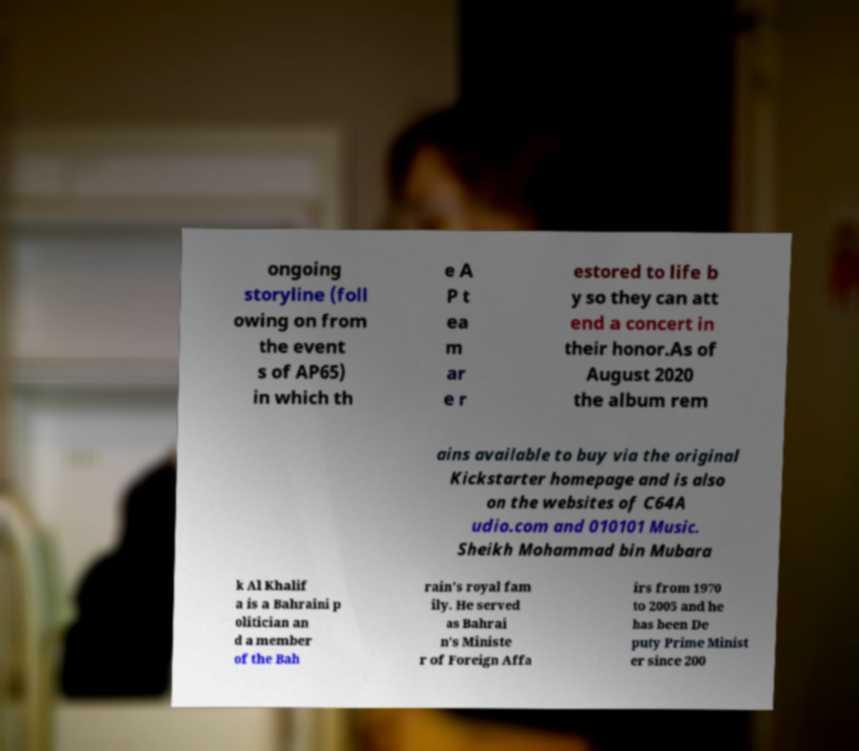Please read and relay the text visible in this image. What does it say? ongoing storyline (foll owing on from the event s of AP65) in which th e A P t ea m ar e r estored to life b y so they can att end a concert in their honor.As of August 2020 the album rem ains available to buy via the original Kickstarter homepage and is also on the websites of C64A udio.com and 010101 Music. Sheikh Mohammad bin Mubara k Al Khalif a is a Bahraini p olitician an d a member of the Bah rain's royal fam ily. He served as Bahrai n's Ministe r of Foreign Affa irs from 1970 to 2005 and he has been De puty Prime Minist er since 200 